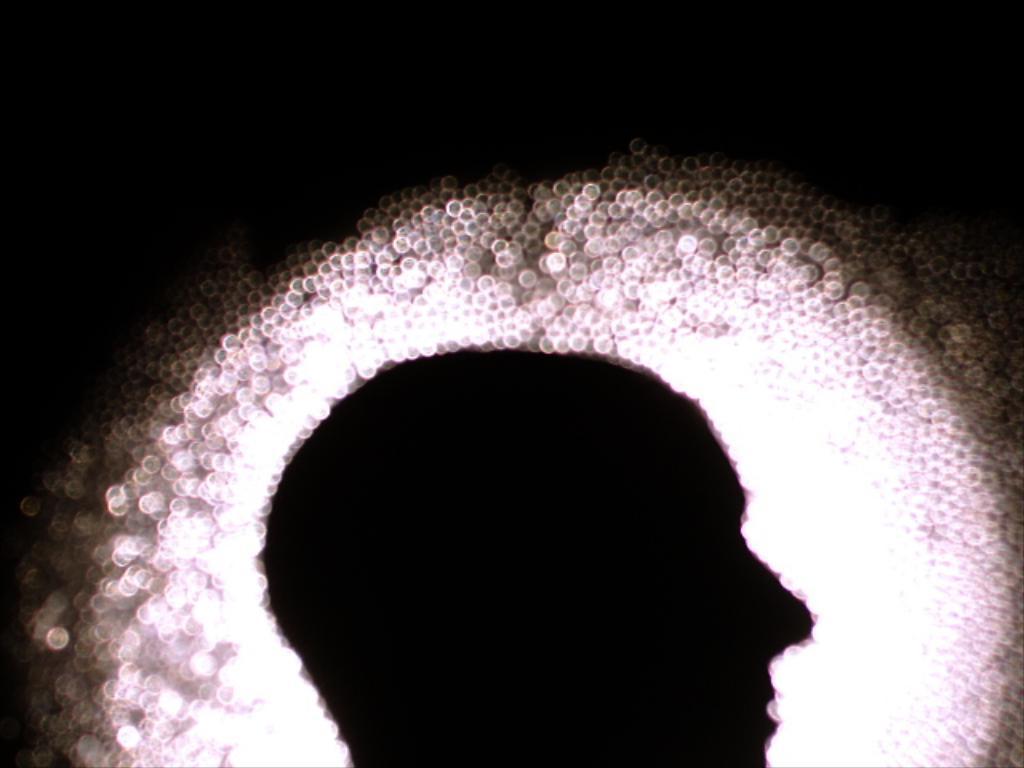Describe this image in one or two sentences. In this picture we can see a person face, lights and in the background it is dark. 